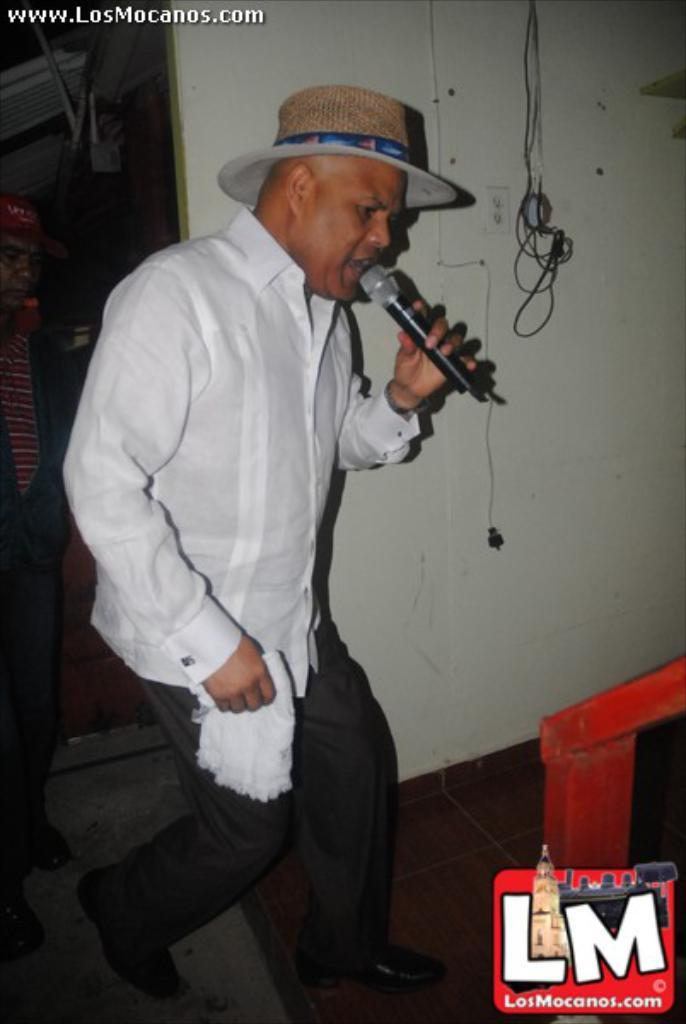What can be seen in the background of the image? There is a wall and wires in the background of the image. What is the man in the image wearing? The man is wearing a white shirt and a hat. What is the man holding in his hand? The man is holding a microphone in his hand. What is the man doing in the image? The man is singing. What type of crown is the man wearing in the image? The man is not wearing a crown in the image; he is wearing a hat. Can you tell me the name of the man's daughter in the image? There is no mention of a daughter in the image or the provided facts. 